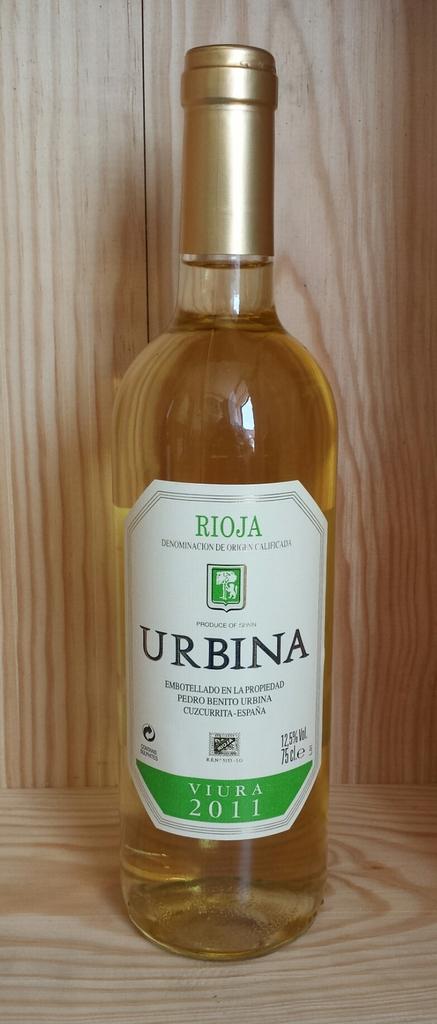What year was this wine made?
Offer a terse response. 2011. 